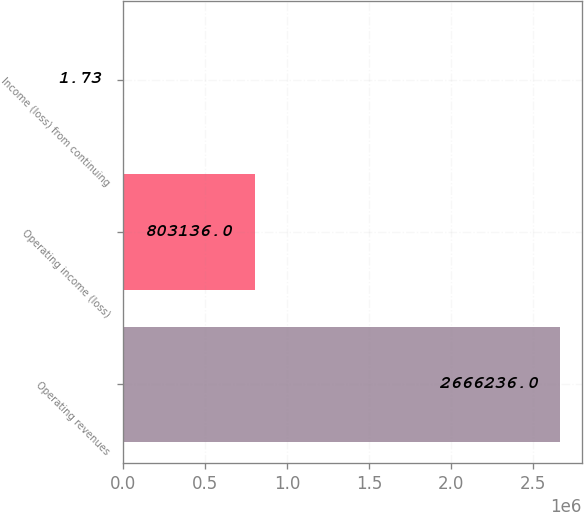Convert chart. <chart><loc_0><loc_0><loc_500><loc_500><bar_chart><fcel>Operating revenues<fcel>Operating income (loss)<fcel>Income (loss) from continuing<nl><fcel>2.66624e+06<fcel>803136<fcel>1.73<nl></chart> 